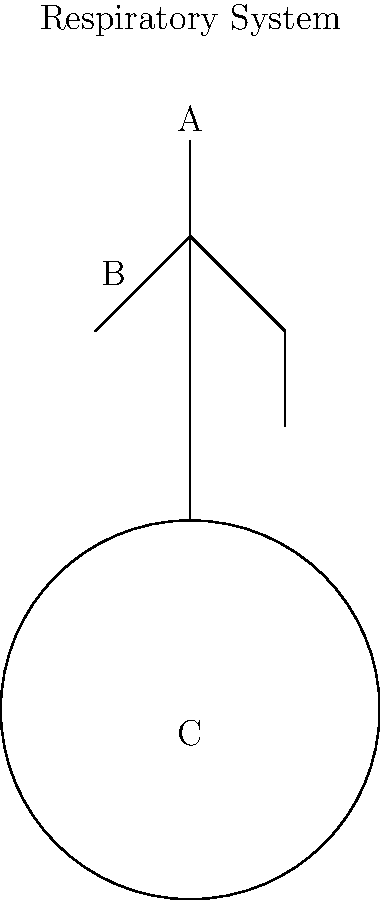In the diagram of the respiratory system, which part labeled A, B, or C is responsible for the exchange of oxygen and carbon dioxide with the bloodstream? To answer this question, let's examine each labeled part and its function in the respiratory system:

1. Part A: This is the trachea, also known as the windpipe. Its primary function is to conduct air from the larynx to the bronchi.

2. Part B: These are the bronchi, which branch off from the trachea and conduct air into the lungs.

3. Part C: This represents the lungs. The lungs are the primary organs of the respiratory system where gas exchange occurs.

The exchange of oxygen and carbon dioxide with the bloodstream takes place in tiny air sacs called alveoli, which are located in the lungs. The alveoli have very thin walls and are surrounded by capillaries, allowing for efficient gas exchange.

As a frontline nurse, you would be familiar with the importance of lung function in patient care, especially in critical situations where oxygen therapy might be required.

Therefore, the correct answer is C, representing the lungs, where the alveoli facilitate the exchange of oxygen and carbon dioxide with the bloodstream.
Answer: C (lungs) 